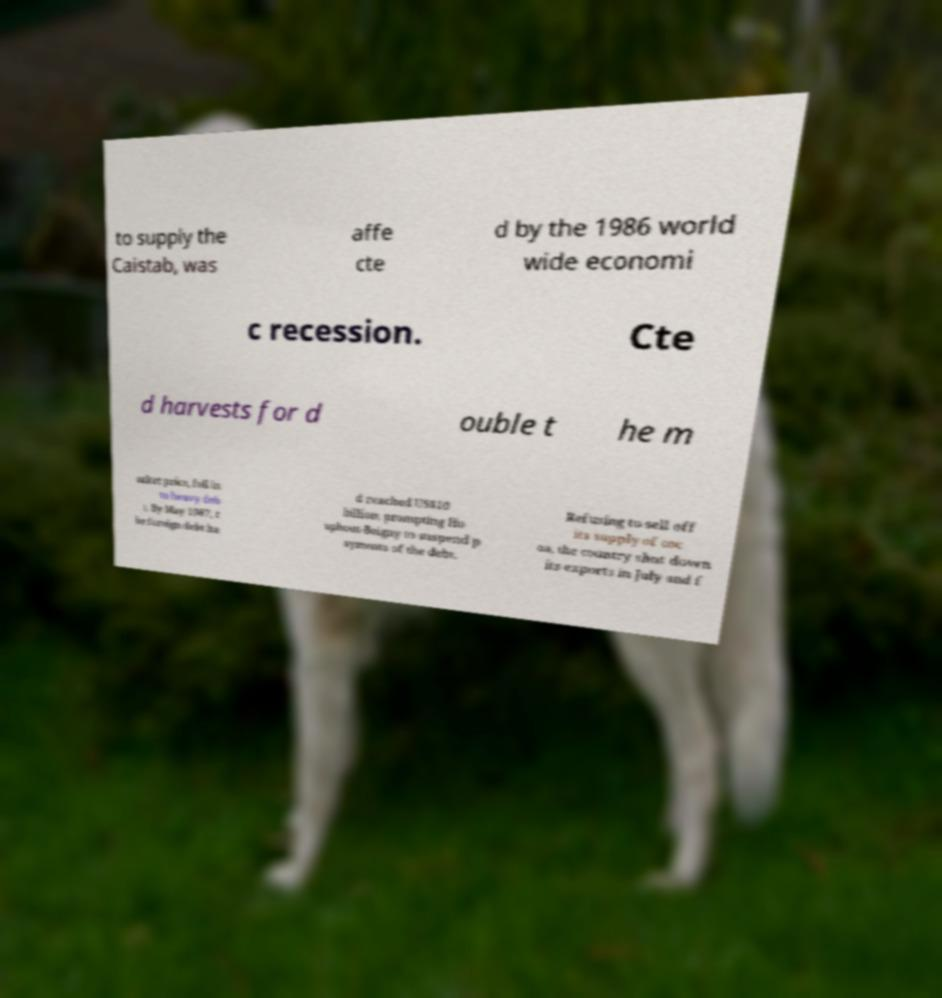There's text embedded in this image that I need extracted. Can you transcribe it verbatim? to supply the Caistab, was affe cte d by the 1986 world wide economi c recession. Cte d harvests for d ouble t he m arket price, fell in to heavy deb t. By May 1987, t he foreign debt ha d reached US$10 billion, prompting Ho uphout-Boigny to suspend p ayments of the debt. Refusing to sell off its supply of coc oa, the country shut down its exports in July and f 